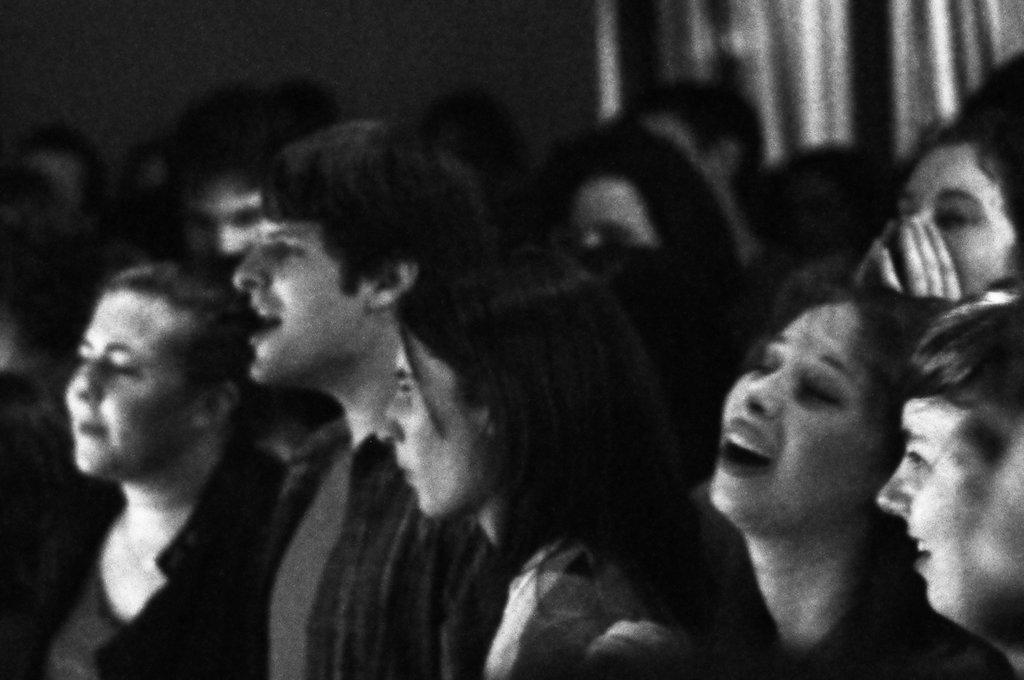Please provide a concise description of this image. This is a black and white image, I can see a group of people and there is a blurred background. 